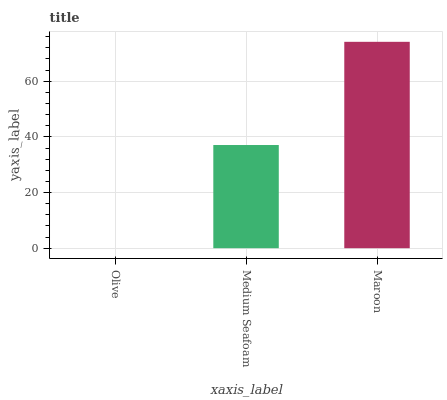Is Olive the minimum?
Answer yes or no. Yes. Is Maroon the maximum?
Answer yes or no. Yes. Is Medium Seafoam the minimum?
Answer yes or no. No. Is Medium Seafoam the maximum?
Answer yes or no. No. Is Medium Seafoam greater than Olive?
Answer yes or no. Yes. Is Olive less than Medium Seafoam?
Answer yes or no. Yes. Is Olive greater than Medium Seafoam?
Answer yes or no. No. Is Medium Seafoam less than Olive?
Answer yes or no. No. Is Medium Seafoam the high median?
Answer yes or no. Yes. Is Medium Seafoam the low median?
Answer yes or no. Yes. Is Olive the high median?
Answer yes or no. No. Is Maroon the low median?
Answer yes or no. No. 